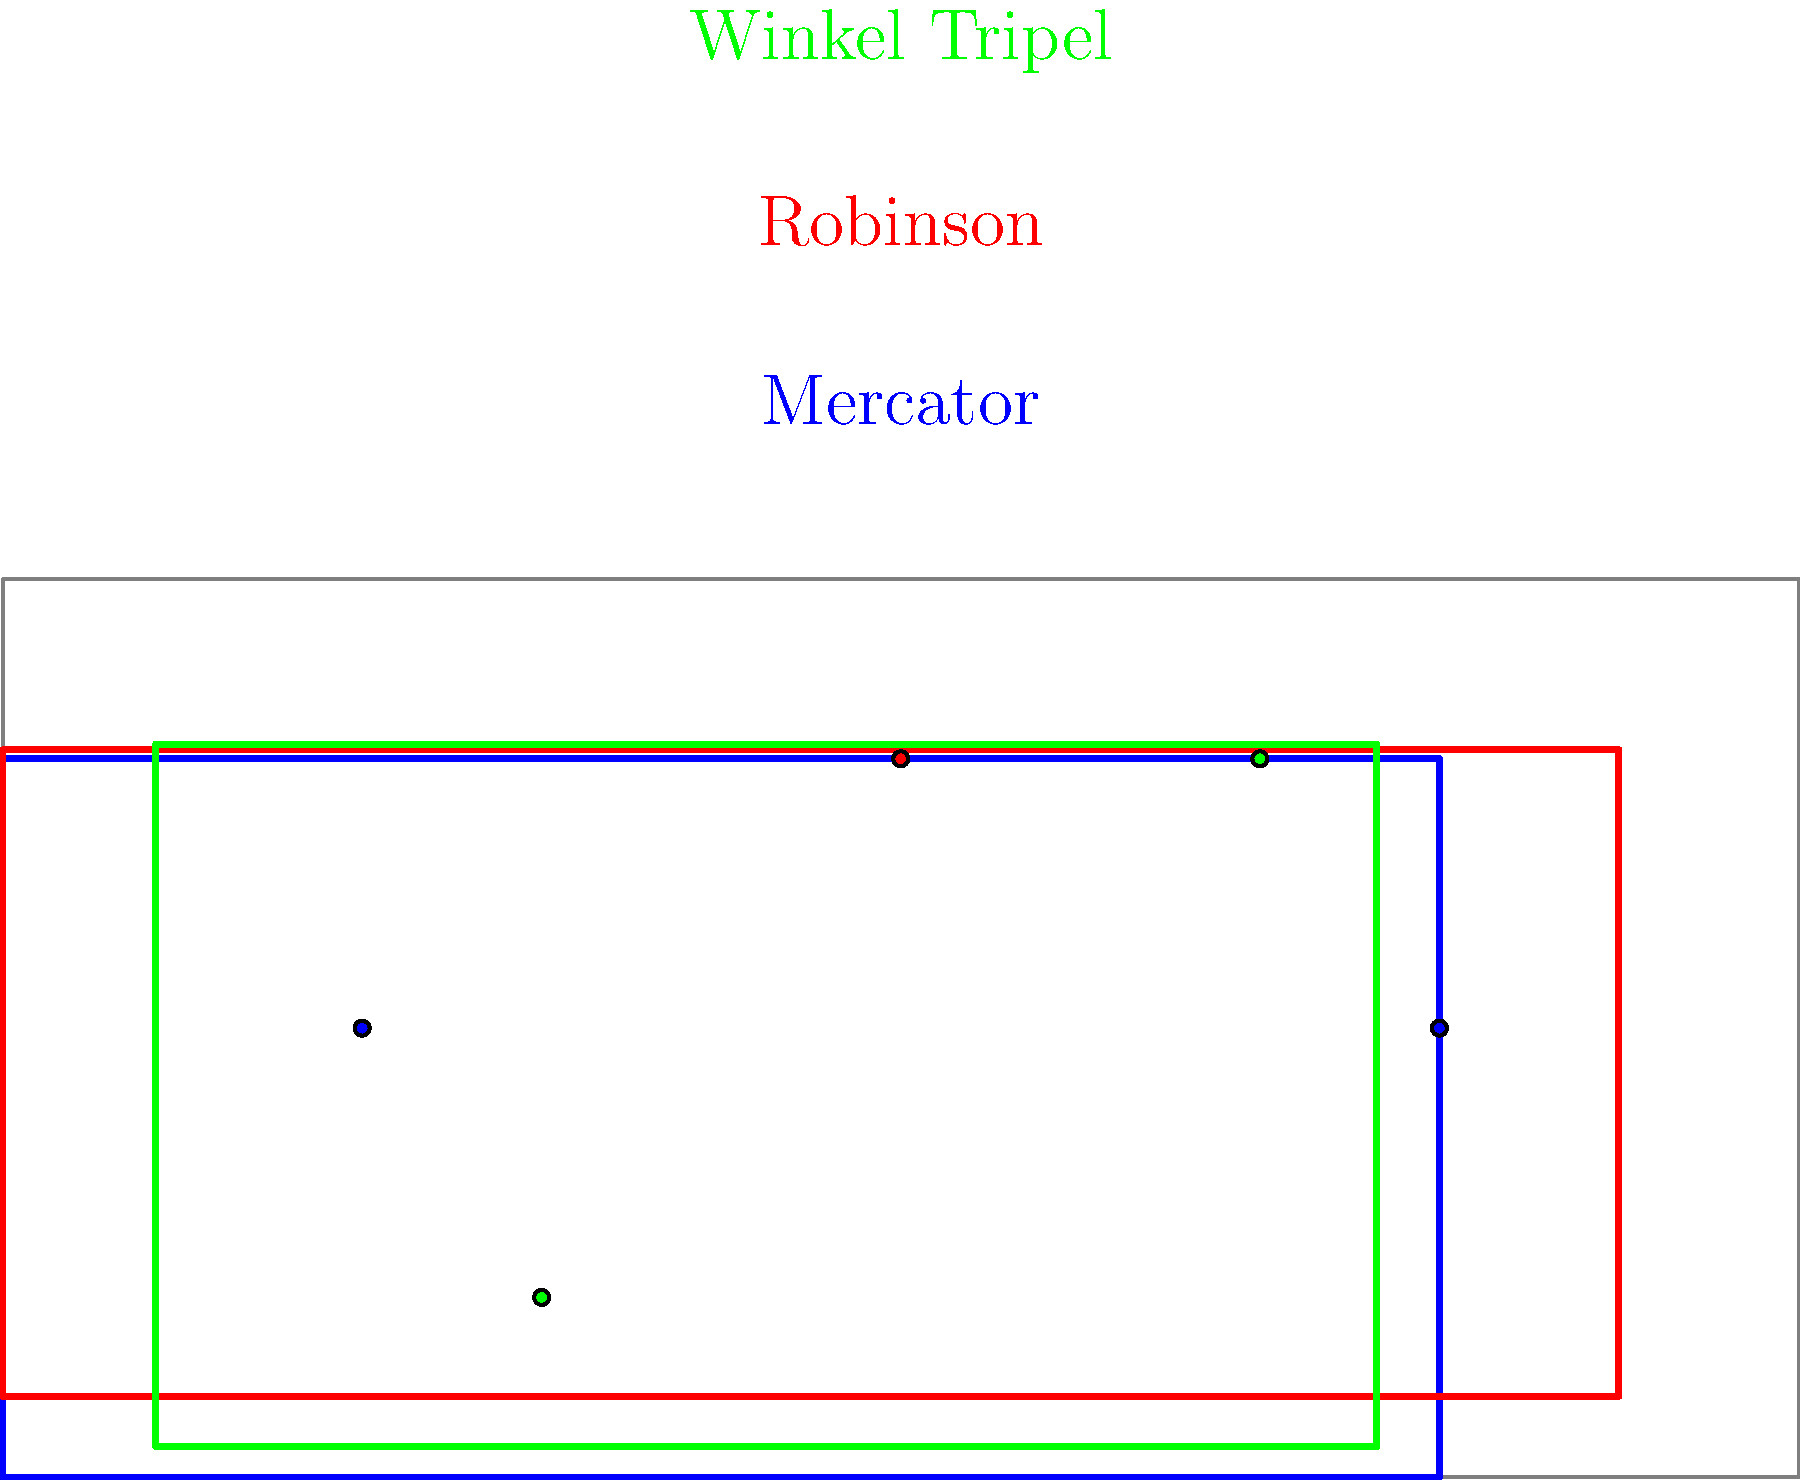As a news editor analyzing global military alliances, which map projection would be most suitable for accurately representing the relative sizes of countries and maintaining directional accuracy, especially when considering alliances spanning large distances? To answer this question, we need to consider the properties of different map projections and their suitability for analyzing global military alliances:

1. Mercator Projection (blue):
   - Preserves angles and shapes of small areas
   - Severely distorts sizes, especially near the poles
   - Not ideal for comparing country sizes or analyzing global patterns

2. Robinson Projection (red):
   - Compromise projection that reduces distortion
   - Reasonably accurate representation of area and shape
   - Good for general-purpose world maps, but not the best for specific analytical purposes

3. Winkel Tripel Projection (green):
   - Balances the distortion of area, direction, and distance
   - Provides a good compromise for representing the entire world
   - Maintains relatively accurate sizes of countries and continents
   - Preserves directional relationships reasonably well

For analyzing global military alliances, we need a projection that:
a) Accurately represents the relative sizes of countries
b) Maintains directional accuracy for alliances spanning large distances
c) Provides a balanced view of the entire world

The Winkel Tripel projection best meets these criteria. It offers a good compromise between area and directional accuracy, which is crucial for understanding the strategic implications of military alliances on a global scale. The relatively accurate representation of country sizes helps in assessing the potential strength and resources of alliance members, while the balanced distortion allows for a more accurate analysis of global patterns and relationships.
Answer: Winkel Tripel projection 